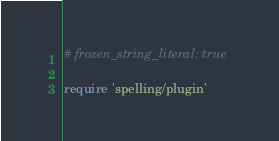Convert code to text. <code><loc_0><loc_0><loc_500><loc_500><_Ruby_># frozen_string_literal: true

require 'spelling/plugin'
</code> 